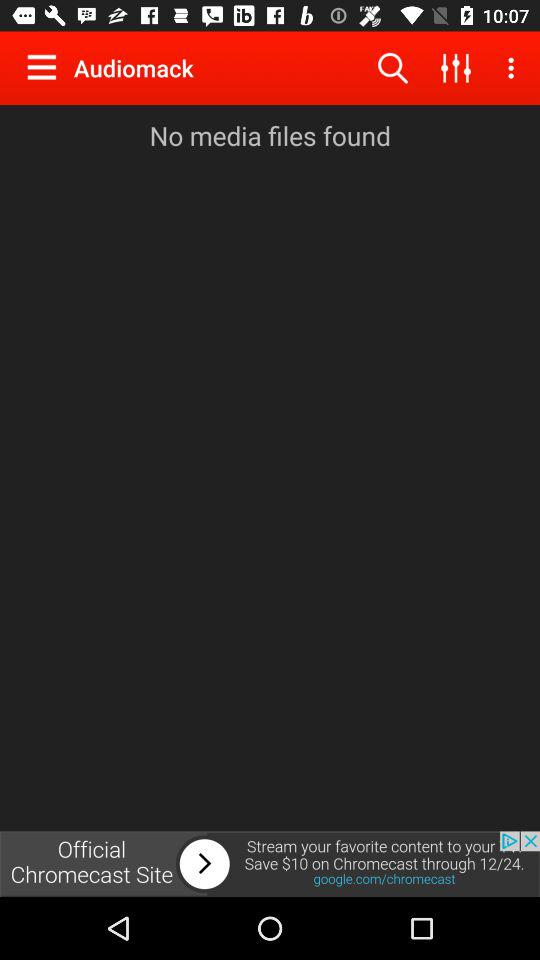How many media files are there? There are no media files. 